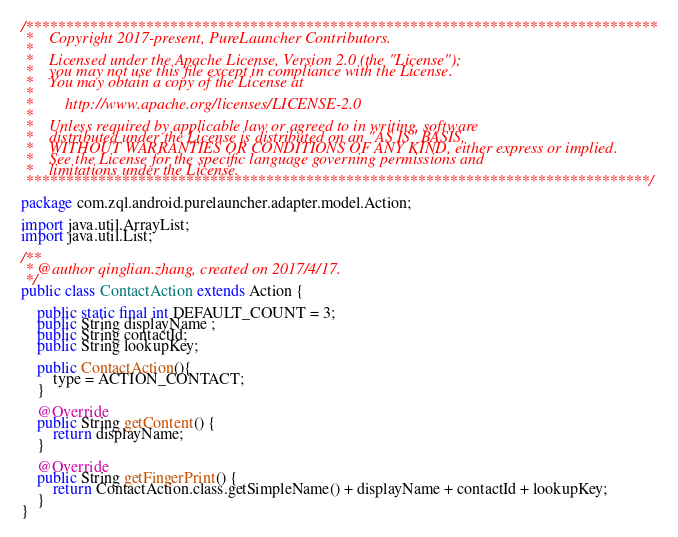<code> <loc_0><loc_0><loc_500><loc_500><_Java_>/*******************************************************************************
 *    Copyright 2017-present, PureLauncher Contributors.
 *
 *    Licensed under the Apache License, Version 2.0 (the "License");
 *    you may not use this file except in compliance with the License.
 *    You may obtain a copy of the License at
 *
 *        http://www.apache.org/licenses/LICENSE-2.0
 *
 *    Unless required by applicable law or agreed to in writing, software
 *    distributed under the License is distributed on an "AS IS" BASIS,
 *    WITHOUT WARRANTIES OR CONDITIONS OF ANY KIND, either express or implied.
 *    See the License for the specific language governing permissions and
 *    limitations under the License.
 ******************************************************************************/

package com.zql.android.purelauncher.adapter.model.Action;

import java.util.ArrayList;
import java.util.List;

/**
 * @author qinglian.zhang, created on 2017/4/17.
 */
public class ContactAction extends Action {

    public static final int DEFAULT_COUNT = 3;
    public String displayName ;
    public String contactId;
    public String lookupKey;

    public ContactAction(){
        type = ACTION_CONTACT;
    }

    @Override
    public String getContent() {
        return displayName;
    }

    @Override
    public String getFingerPrint() {
        return ContactAction.class.getSimpleName() + displayName + contactId + lookupKey;
    }
}
</code> 